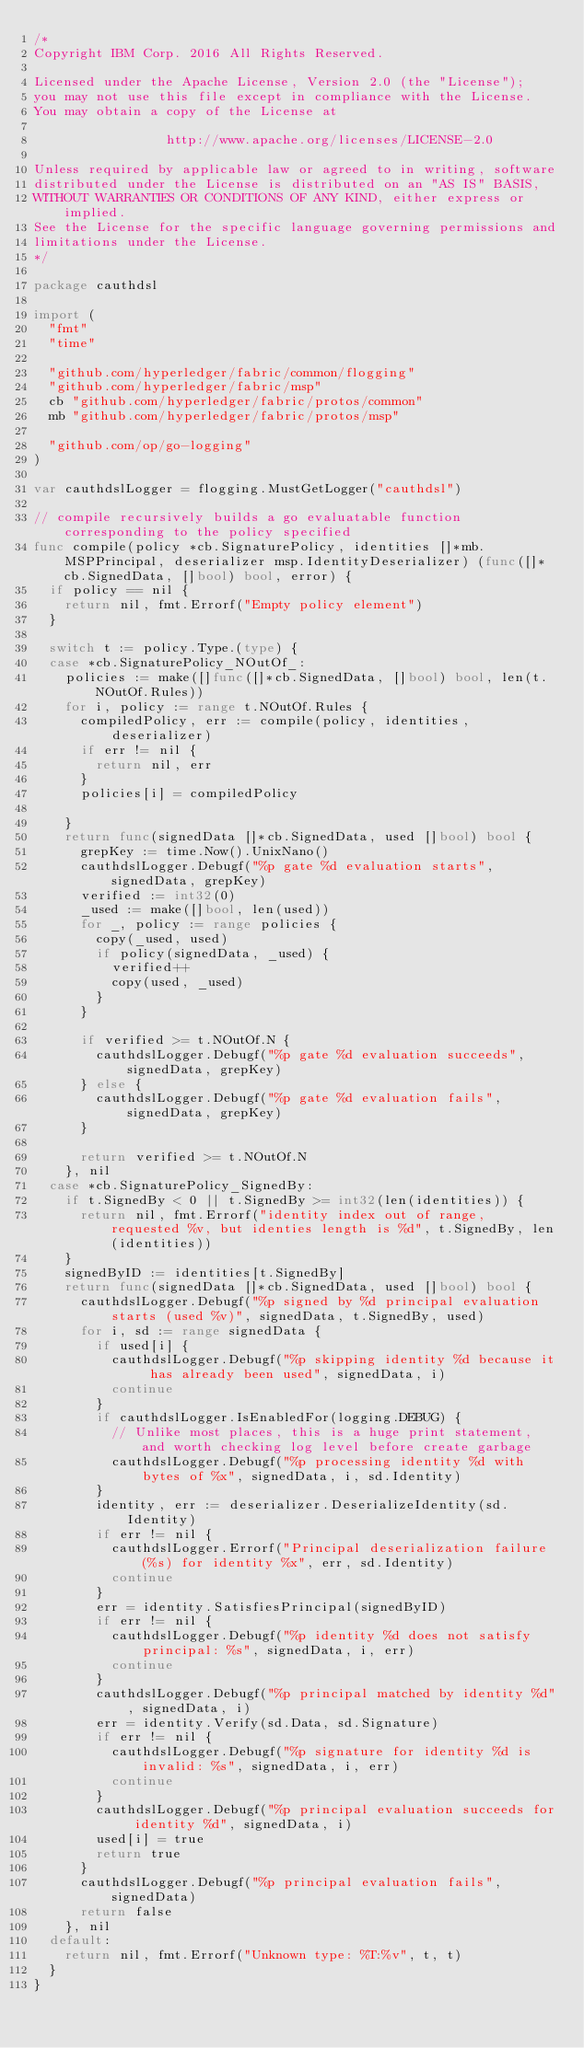Convert code to text. <code><loc_0><loc_0><loc_500><loc_500><_Go_>/*
Copyright IBM Corp. 2016 All Rights Reserved.

Licensed under the Apache License, Version 2.0 (the "License");
you may not use this file except in compliance with the License.
You may obtain a copy of the License at

                 http://www.apache.org/licenses/LICENSE-2.0

Unless required by applicable law or agreed to in writing, software
distributed under the License is distributed on an "AS IS" BASIS,
WITHOUT WARRANTIES OR CONDITIONS OF ANY KIND, either express or implied.
See the License for the specific language governing permissions and
limitations under the License.
*/

package cauthdsl

import (
	"fmt"
	"time"

	"github.com/hyperledger/fabric/common/flogging"
	"github.com/hyperledger/fabric/msp"
	cb "github.com/hyperledger/fabric/protos/common"
	mb "github.com/hyperledger/fabric/protos/msp"

	"github.com/op/go-logging"
)

var cauthdslLogger = flogging.MustGetLogger("cauthdsl")

// compile recursively builds a go evaluatable function corresponding to the policy specified
func compile(policy *cb.SignaturePolicy, identities []*mb.MSPPrincipal, deserializer msp.IdentityDeserializer) (func([]*cb.SignedData, []bool) bool, error) {
	if policy == nil {
		return nil, fmt.Errorf("Empty policy element")
	}

	switch t := policy.Type.(type) {
	case *cb.SignaturePolicy_NOutOf_:
		policies := make([]func([]*cb.SignedData, []bool) bool, len(t.NOutOf.Rules))
		for i, policy := range t.NOutOf.Rules {
			compiledPolicy, err := compile(policy, identities, deserializer)
			if err != nil {
				return nil, err
			}
			policies[i] = compiledPolicy

		}
		return func(signedData []*cb.SignedData, used []bool) bool {
			grepKey := time.Now().UnixNano()
			cauthdslLogger.Debugf("%p gate %d evaluation starts", signedData, grepKey)
			verified := int32(0)
			_used := make([]bool, len(used))
			for _, policy := range policies {
				copy(_used, used)
				if policy(signedData, _used) {
					verified++
					copy(used, _used)
				}
			}

			if verified >= t.NOutOf.N {
				cauthdslLogger.Debugf("%p gate %d evaluation succeeds", signedData, grepKey)
			} else {
				cauthdslLogger.Debugf("%p gate %d evaluation fails", signedData, grepKey)
			}

			return verified >= t.NOutOf.N
		}, nil
	case *cb.SignaturePolicy_SignedBy:
		if t.SignedBy < 0 || t.SignedBy >= int32(len(identities)) {
			return nil, fmt.Errorf("identity index out of range, requested %v, but identies length is %d", t.SignedBy, len(identities))
		}
		signedByID := identities[t.SignedBy]
		return func(signedData []*cb.SignedData, used []bool) bool {
			cauthdslLogger.Debugf("%p signed by %d principal evaluation starts (used %v)", signedData, t.SignedBy, used)
			for i, sd := range signedData {
				if used[i] {
					cauthdslLogger.Debugf("%p skipping identity %d because it has already been used", signedData, i)
					continue
				}
				if cauthdslLogger.IsEnabledFor(logging.DEBUG) {
					// Unlike most places, this is a huge print statement, and worth checking log level before create garbage
					cauthdslLogger.Debugf("%p processing identity %d with bytes of %x", signedData, i, sd.Identity)
				}
				identity, err := deserializer.DeserializeIdentity(sd.Identity)
				if err != nil {
					cauthdslLogger.Errorf("Principal deserialization failure (%s) for identity %x", err, sd.Identity)
					continue
				}
				err = identity.SatisfiesPrincipal(signedByID)
				if err != nil {
					cauthdslLogger.Debugf("%p identity %d does not satisfy principal: %s", signedData, i, err)
					continue
				}
				cauthdslLogger.Debugf("%p principal matched by identity %d", signedData, i)
				err = identity.Verify(sd.Data, sd.Signature)
				if err != nil {
					cauthdslLogger.Debugf("%p signature for identity %d is invalid: %s", signedData, i, err)
					continue
				}
				cauthdslLogger.Debugf("%p principal evaluation succeeds for identity %d", signedData, i)
				used[i] = true
				return true
			}
			cauthdslLogger.Debugf("%p principal evaluation fails", signedData)
			return false
		}, nil
	default:
		return nil, fmt.Errorf("Unknown type: %T:%v", t, t)
	}
}
</code> 